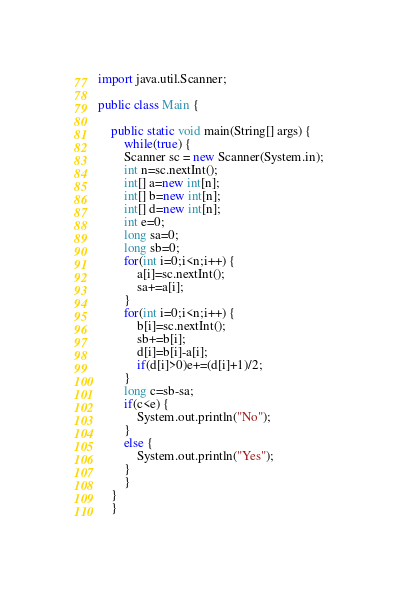<code> <loc_0><loc_0><loc_500><loc_500><_Java_>import java.util.Scanner;

public class Main {

	public static void main(String[] args) {
		while(true) {
		Scanner sc = new Scanner(System.in);
		int n=sc.nextInt();
		int[] a=new int[n];
		int[] b=new int[n];
		int[] d=new int[n];
		int e=0;
		long sa=0;
		long sb=0;
		for(int i=0;i<n;i++) {
			a[i]=sc.nextInt();
			sa+=a[i];
		}
		for(int i=0;i<n;i++) {
			b[i]=sc.nextInt();
			sb+=b[i];
			d[i]=b[i]-a[i];
			if(d[i]>0)e+=(d[i]+1)/2;
		}
		long c=sb-sa;
		if(c<e) {
			System.out.println("No");
		}
		else {
			System.out.println("Yes");
		}
		}
	}
	}
</code> 